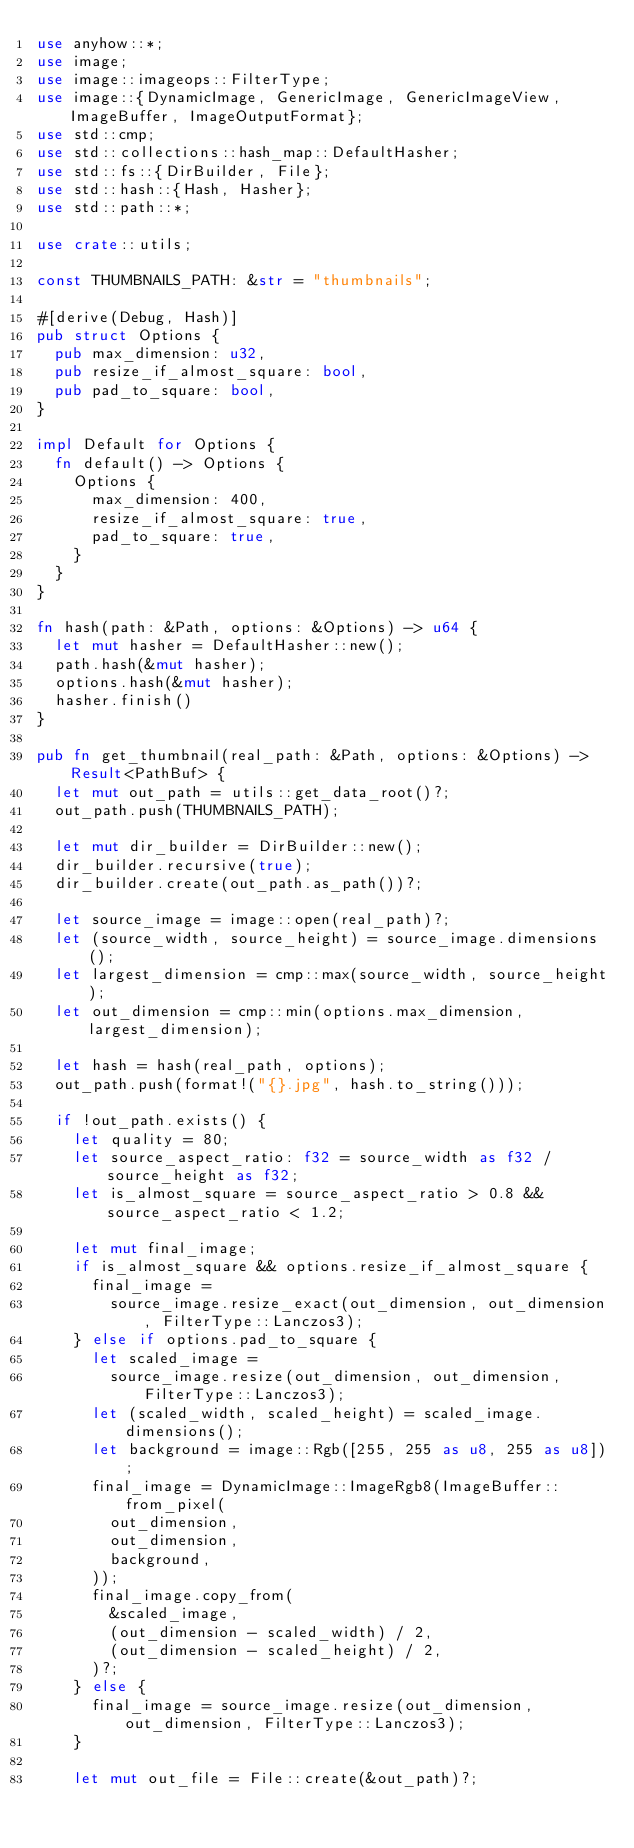Convert code to text. <code><loc_0><loc_0><loc_500><loc_500><_Rust_>use anyhow::*;
use image;
use image::imageops::FilterType;
use image::{DynamicImage, GenericImage, GenericImageView, ImageBuffer, ImageOutputFormat};
use std::cmp;
use std::collections::hash_map::DefaultHasher;
use std::fs::{DirBuilder, File};
use std::hash::{Hash, Hasher};
use std::path::*;

use crate::utils;

const THUMBNAILS_PATH: &str = "thumbnails";

#[derive(Debug, Hash)]
pub struct Options {
	pub max_dimension: u32,
	pub resize_if_almost_square: bool,
	pub pad_to_square: bool,
}

impl Default for Options {
	fn default() -> Options {
		Options {
			max_dimension: 400,
			resize_if_almost_square: true,
			pad_to_square: true,
		}
	}
}

fn hash(path: &Path, options: &Options) -> u64 {
	let mut hasher = DefaultHasher::new();
	path.hash(&mut hasher);
	options.hash(&mut hasher);
	hasher.finish()
}

pub fn get_thumbnail(real_path: &Path, options: &Options) -> Result<PathBuf> {
	let mut out_path = utils::get_data_root()?;
	out_path.push(THUMBNAILS_PATH);

	let mut dir_builder = DirBuilder::new();
	dir_builder.recursive(true);
	dir_builder.create(out_path.as_path())?;

	let source_image = image::open(real_path)?;
	let (source_width, source_height) = source_image.dimensions();
	let largest_dimension = cmp::max(source_width, source_height);
	let out_dimension = cmp::min(options.max_dimension, largest_dimension);

	let hash = hash(real_path, options);
	out_path.push(format!("{}.jpg", hash.to_string()));

	if !out_path.exists() {
		let quality = 80;
		let source_aspect_ratio: f32 = source_width as f32 / source_height as f32;
		let is_almost_square = source_aspect_ratio > 0.8 && source_aspect_ratio < 1.2;

		let mut final_image;
		if is_almost_square && options.resize_if_almost_square {
			final_image =
				source_image.resize_exact(out_dimension, out_dimension, FilterType::Lanczos3);
		} else if options.pad_to_square {
			let scaled_image =
				source_image.resize(out_dimension, out_dimension, FilterType::Lanczos3);
			let (scaled_width, scaled_height) = scaled_image.dimensions();
			let background = image::Rgb([255, 255 as u8, 255 as u8]);
			final_image = DynamicImage::ImageRgb8(ImageBuffer::from_pixel(
				out_dimension,
				out_dimension,
				background,
			));
			final_image.copy_from(
				&scaled_image,
				(out_dimension - scaled_width) / 2,
				(out_dimension - scaled_height) / 2,
			)?;
		} else {
			final_image = source_image.resize(out_dimension, out_dimension, FilterType::Lanczos3);
		}

		let mut out_file = File::create(&out_path)?;</code> 